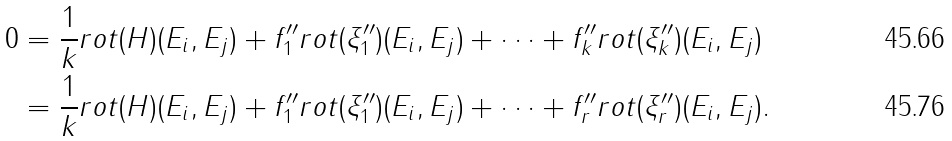<formula> <loc_0><loc_0><loc_500><loc_500>0 & = \frac { 1 } { k } r o t ( H ) ( E _ { i } , E _ { j } ) + f _ { 1 } ^ { \prime \prime } r o t ( \xi _ { 1 } ^ { \prime \prime } ) ( E _ { i } , E _ { j } ) + \dots + f _ { k } ^ { \prime \prime } r o t ( \xi _ { k } ^ { \prime \prime } ) ( E _ { i } , E _ { j } ) \\ & = \frac { 1 } { k } r o t ( H ) ( E _ { i } , E _ { j } ) + f _ { 1 } ^ { \prime \prime } r o t ( \xi _ { 1 } ^ { \prime \prime } ) ( E _ { i } , E _ { j } ) + \dots + f _ { r } ^ { \prime \prime } r o t ( \xi _ { r } ^ { \prime \prime } ) ( E _ { i } , E _ { j } ) .</formula> 